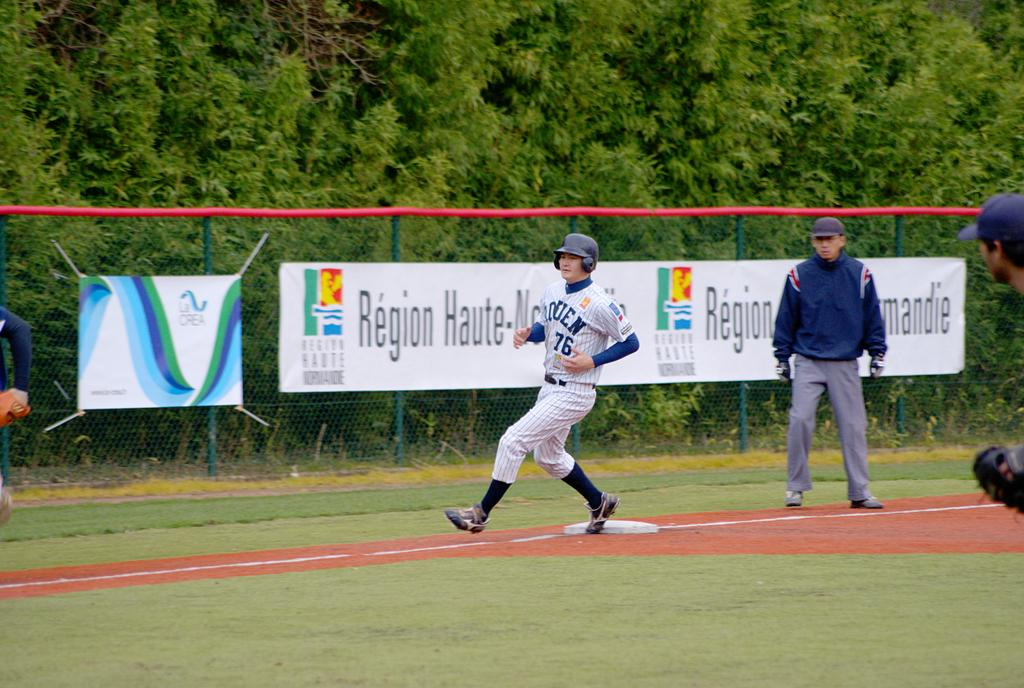<image>
Relay a brief, clear account of the picture shown. Number 76 is shown on the jersey of the player rounding the bases. 